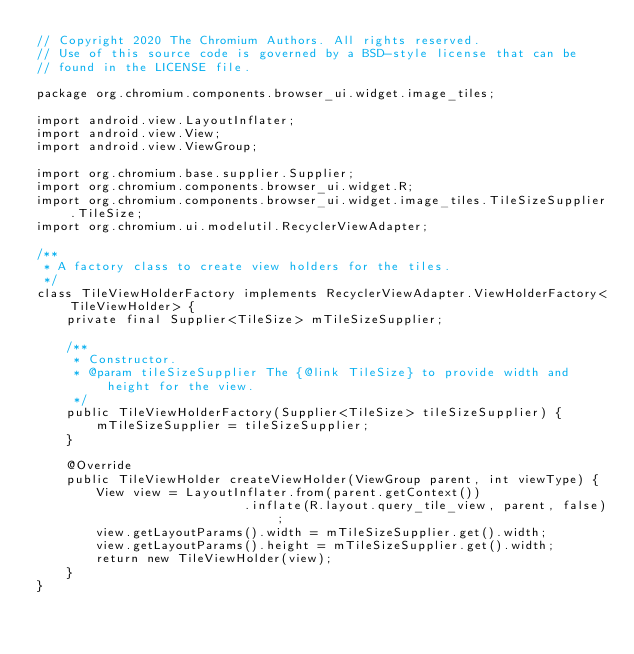Convert code to text. <code><loc_0><loc_0><loc_500><loc_500><_Java_>// Copyright 2020 The Chromium Authors. All rights reserved.
// Use of this source code is governed by a BSD-style license that can be
// found in the LICENSE file.

package org.chromium.components.browser_ui.widget.image_tiles;

import android.view.LayoutInflater;
import android.view.View;
import android.view.ViewGroup;

import org.chromium.base.supplier.Supplier;
import org.chromium.components.browser_ui.widget.R;
import org.chromium.components.browser_ui.widget.image_tiles.TileSizeSupplier.TileSize;
import org.chromium.ui.modelutil.RecyclerViewAdapter;

/**
 * A factory class to create view holders for the tiles.
 */
class TileViewHolderFactory implements RecyclerViewAdapter.ViewHolderFactory<TileViewHolder> {
    private final Supplier<TileSize> mTileSizeSupplier;

    /**
     * Constructor.
     * @param tileSizeSupplier The {@link TileSize} to provide width and height for the view.
     */
    public TileViewHolderFactory(Supplier<TileSize> tileSizeSupplier) {
        mTileSizeSupplier = tileSizeSupplier;
    }

    @Override
    public TileViewHolder createViewHolder(ViewGroup parent, int viewType) {
        View view = LayoutInflater.from(parent.getContext())
                            .inflate(R.layout.query_tile_view, parent, false);
        view.getLayoutParams().width = mTileSizeSupplier.get().width;
        view.getLayoutParams().height = mTileSizeSupplier.get().width;
        return new TileViewHolder(view);
    }
}
</code> 